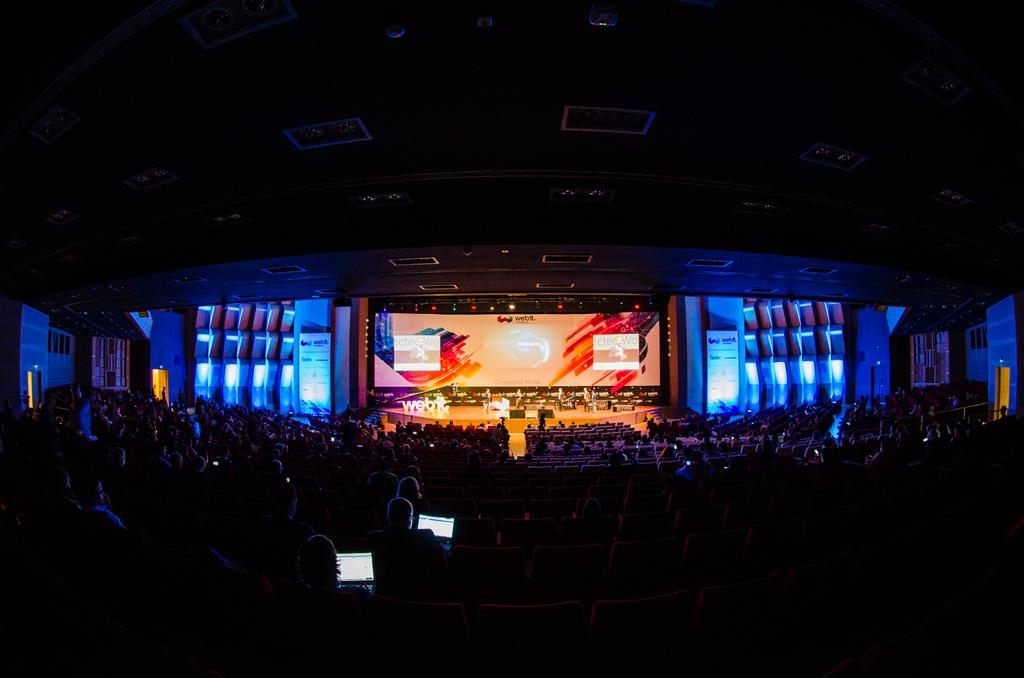How many people are in the image? There is a group of people in the image, but the exact number cannot be determined from the provided facts. What can be seen in the background of the image? There are lights, hoardings, and a projector screen visible in the background of the image. What electronic devices are visible in the image? Laptops are visible in the image. What type of lace is draped over the projector screen in the image? There is no lace draped over the projector screen in the image. What is the price of the hoardings in the image? The price of the hoardings cannot be determined from the image. 